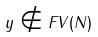Convert formula to latex. <formula><loc_0><loc_0><loc_500><loc_500>y \notin F V ( N )</formula> 